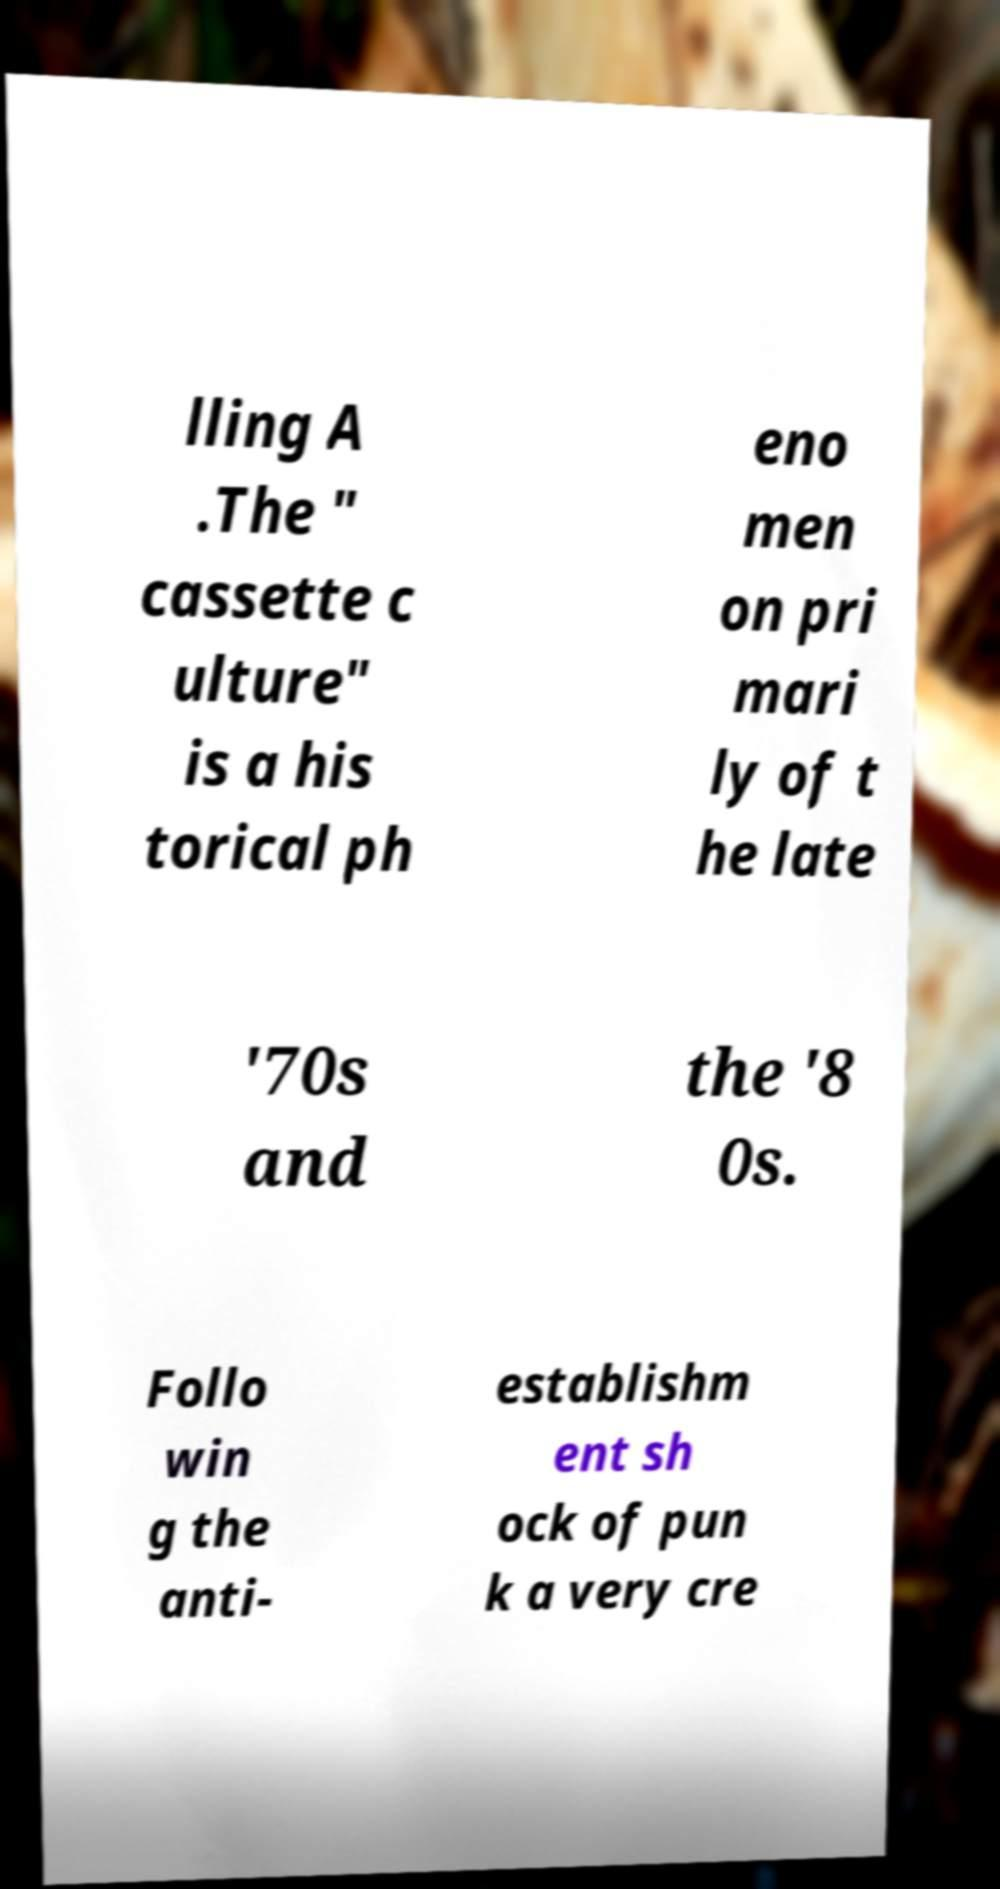Can you read and provide the text displayed in the image?This photo seems to have some interesting text. Can you extract and type it out for me? lling A .The " cassette c ulture" is a his torical ph eno men on pri mari ly of t he late '70s and the '8 0s. Follo win g the anti- establishm ent sh ock of pun k a very cre 